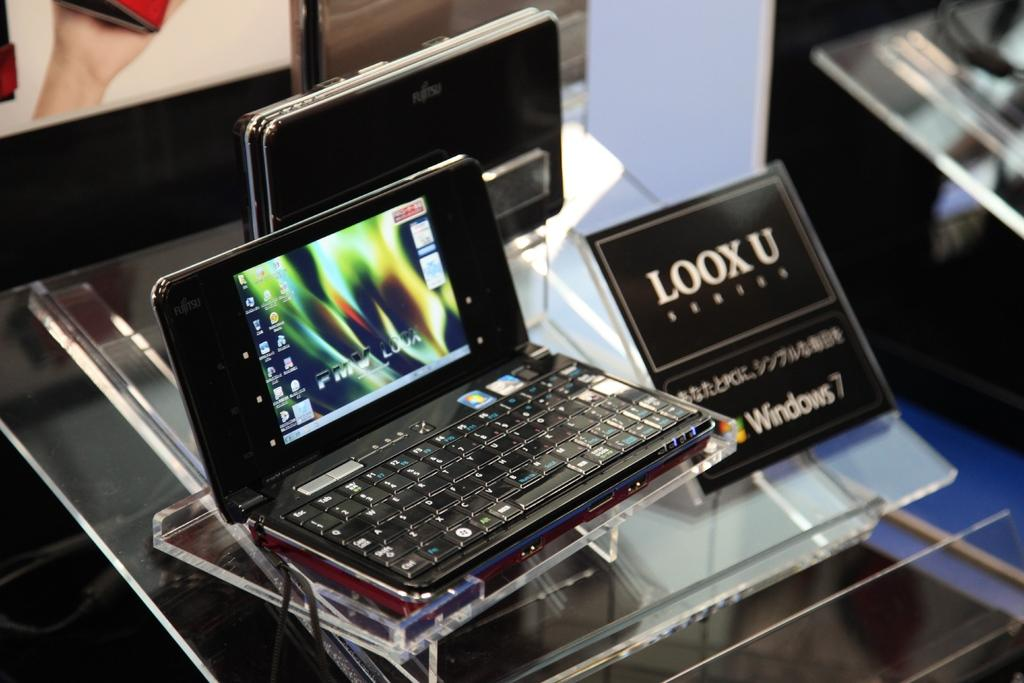What piece of furniture is present in the image? There is a table in the image. What electronic devices are on the table? There are tablets on the table. What is the purpose of the board on the table? The board on the table is likely used for writing or drawing. Can you describe the board visible in the background of the image? There is a board visible in the background of the image, but its purpose or details cannot be determined from the provided facts. How does the stream of water flow in the image? There is no stream of water present in the image. What does the person in the image look like? There is no person present in the image. 